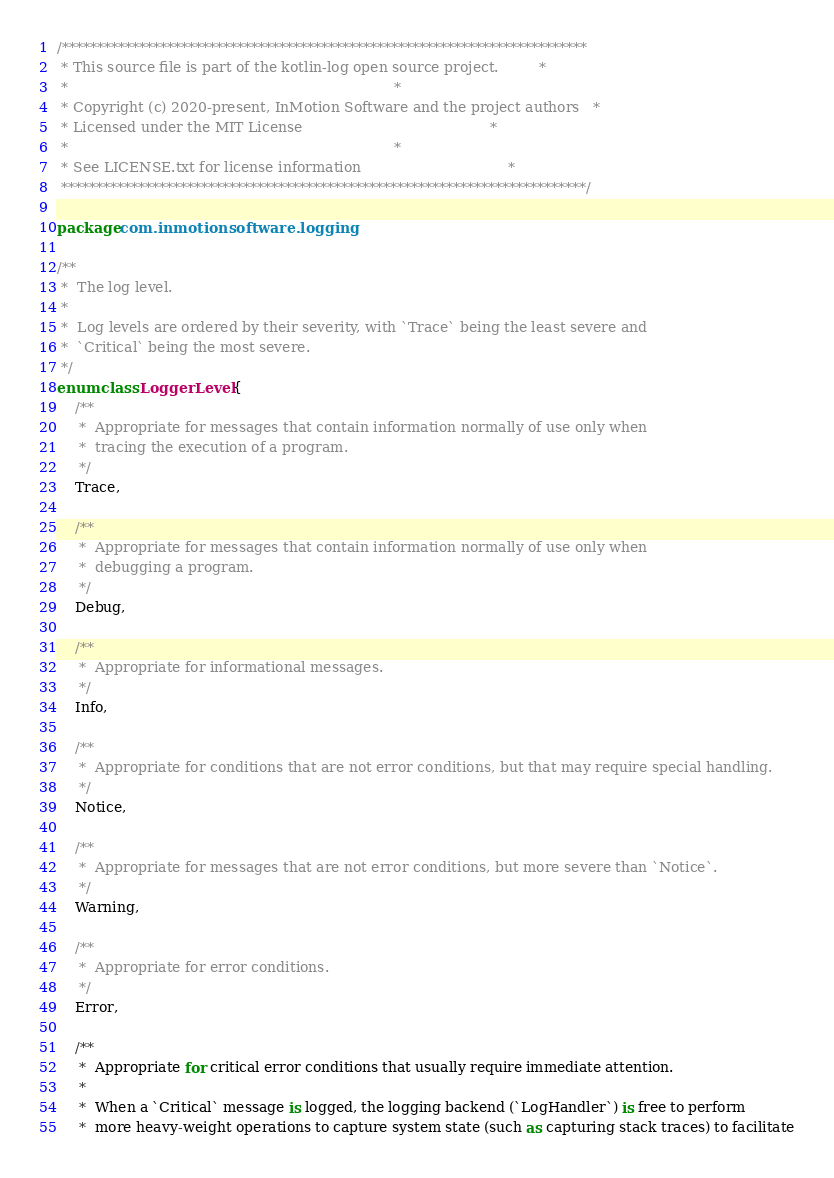<code> <loc_0><loc_0><loc_500><loc_500><_Kotlin_>/***************************************************************************
 * This source file is part of the kotlin-log open source project.         *
 *                                                                         *
 * Copyright (c) 2020-present, InMotion Software and the project authors   *
 * Licensed under the MIT License                                          *
 *                                                                         *
 * See LICENSE.txt for license information                                 *
 ***************************************************************************/

package com.inmotionsoftware.logging

/**
 *  The log level.
 * 
 *  Log levels are ordered by their severity, with `Trace` being the least severe and
 *  `Critical` being the most severe.
 */
enum class LoggerLevel {
    /**
     *  Appropriate for messages that contain information normally of use only when
     *  tracing the execution of a program.
     */
    Trace,

    /**
     *  Appropriate for messages that contain information normally of use only when
     *  debugging a program.
     */
    Debug,

    /**
     *  Appropriate for informational messages.
     */
    Info,

    /**
     *  Appropriate for conditions that are not error conditions, but that may require special handling.
     */
    Notice,

    /**
     *  Appropriate for messages that are not error conditions, but more severe than `Notice`.
     */
    Warning,

    /**
     *  Appropriate for error conditions.
     */
    Error,

    /**
     *  Appropriate for critical error conditions that usually require immediate attention.
     * 
     *  When a `Critical` message is logged, the logging backend (`LogHandler`) is free to perform
     *  more heavy-weight operations to capture system state (such as capturing stack traces) to facilitate</code> 